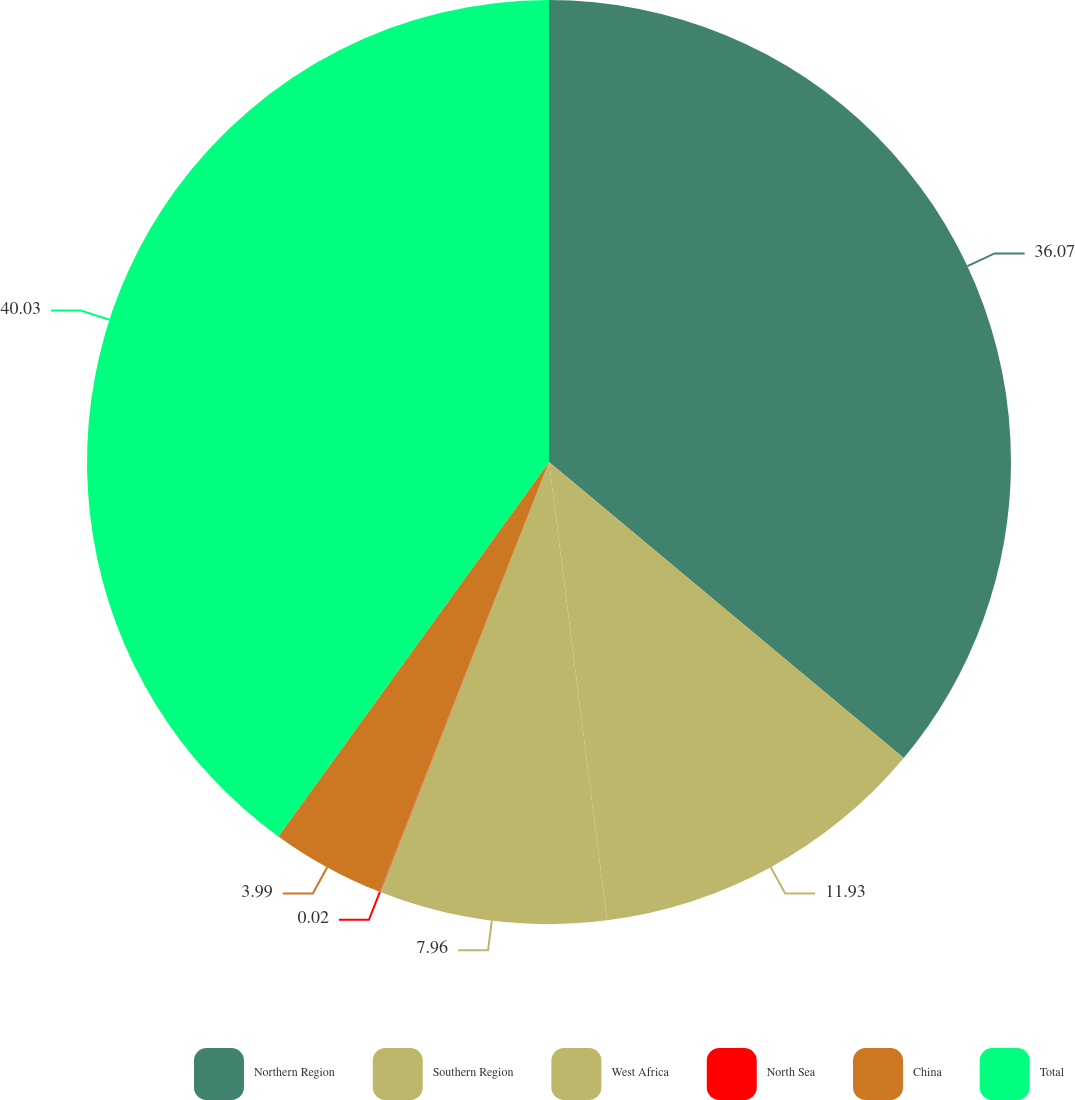Convert chart to OTSL. <chart><loc_0><loc_0><loc_500><loc_500><pie_chart><fcel>Northern Region<fcel>Southern Region<fcel>West Africa<fcel>North Sea<fcel>China<fcel>Total<nl><fcel>36.07%<fcel>11.93%<fcel>7.96%<fcel>0.02%<fcel>3.99%<fcel>40.04%<nl></chart> 